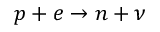<formula> <loc_0><loc_0><loc_500><loc_500>p + e \rightarrow n + \nu</formula> 